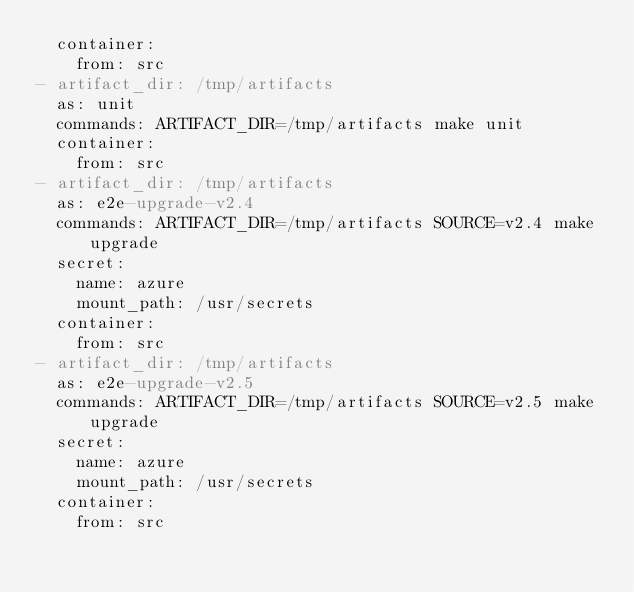Convert code to text. <code><loc_0><loc_0><loc_500><loc_500><_YAML_>  container:
    from: src
- artifact_dir: /tmp/artifacts
  as: unit
  commands: ARTIFACT_DIR=/tmp/artifacts make unit
  container:
    from: src
- artifact_dir: /tmp/artifacts
  as: e2e-upgrade-v2.4
  commands: ARTIFACT_DIR=/tmp/artifacts SOURCE=v2.4 make upgrade
  secret:
    name: azure
    mount_path: /usr/secrets
  container:
    from: src
- artifact_dir: /tmp/artifacts
  as: e2e-upgrade-v2.5
  commands: ARTIFACT_DIR=/tmp/artifacts SOURCE=v2.5 make upgrade
  secret:
    name: azure
    mount_path: /usr/secrets
  container:
    from: src
</code> 